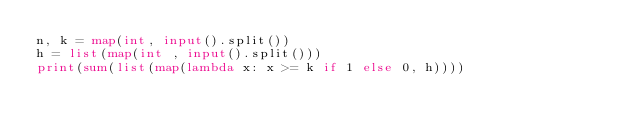<code> <loc_0><loc_0><loc_500><loc_500><_Python_>n, k = map(int, input().split())
h = list(map(int , input().split()))
print(sum(list(map(lambda x: x >= k if 1 else 0, h))))
</code> 